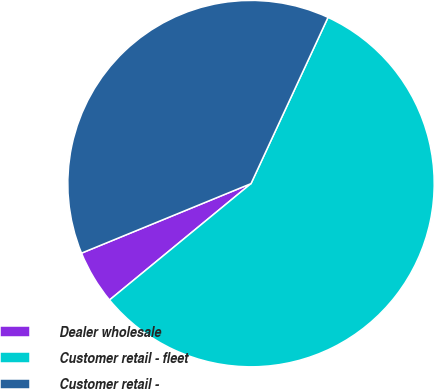<chart> <loc_0><loc_0><loc_500><loc_500><pie_chart><fcel>Dealer wholesale<fcel>Customer retail - fleet<fcel>Customer retail -<nl><fcel>4.76%<fcel>57.14%<fcel>38.1%<nl></chart> 